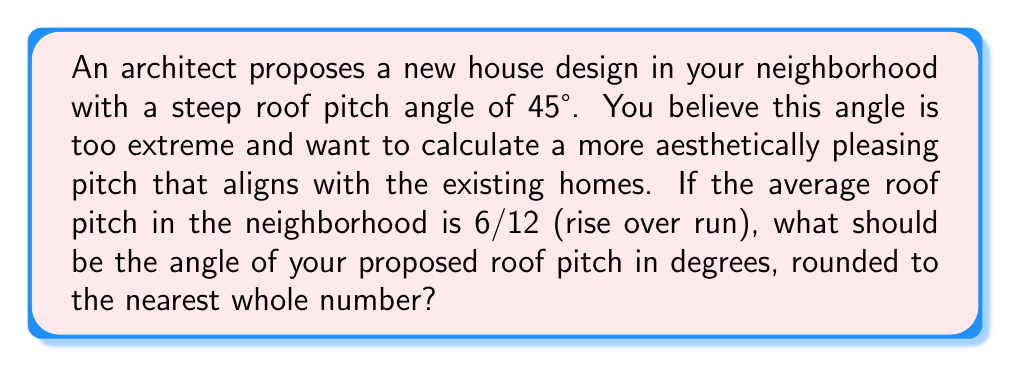Give your solution to this math problem. To solve this problem, we'll follow these steps:

1) First, let's understand what a 6/12 pitch means:
   - For every 12 units of horizontal run, the roof rises 6 units.
   - This can be expressed as a ratio of 6:12 or 1:2.

2) To convert this pitch to an angle, we need to use the arctangent function:
   $$\theta = \arctan(\frac{\text{rise}}{\text{run}})$$

3) Substituting our values:
   $$\theta = \arctan(\frac{6}{12})$$

4) Simplify the fraction:
   $$\theta = \arctan(\frac{1}{2})$$

5) Calculate the angle:
   $$\theta = \arctan(0.5) \approx 0.4636476 \text{ radians}$$

6) Convert radians to degrees:
   $$\theta = 0.4636476 \times \frac{180}{\pi} \approx 26.57°$$

7) Round to the nearest whole number:
   $$\theta \approx 27°$$

Therefore, you should propose a roof pitch angle of 27° to better align with the neighborhood's aesthetic.
Answer: 27° 